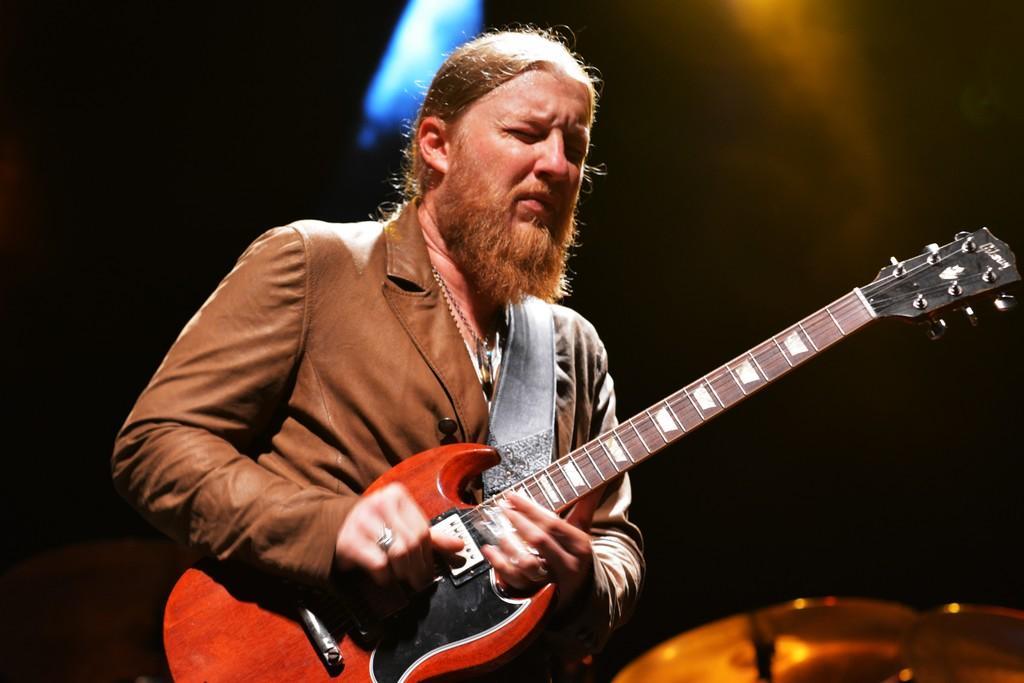Can you describe this image briefly? In this picture a man is playing a guitar in a musical concert , the background is black in color. 